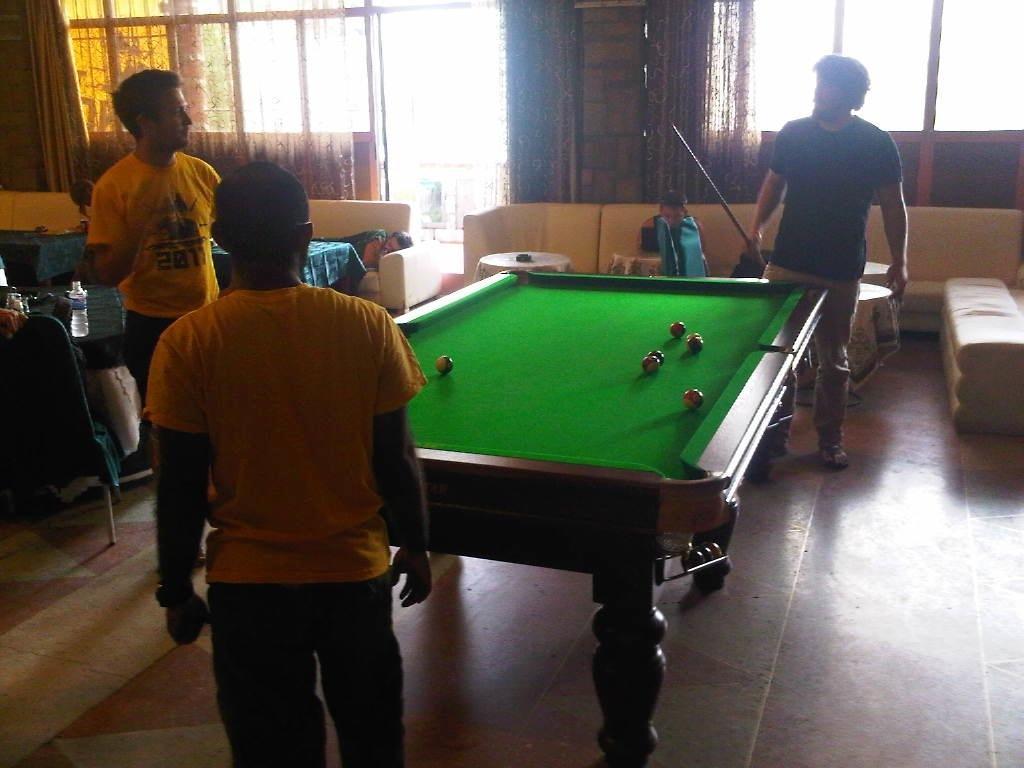Can you describe this image briefly? In this picture three of the people are playing snooker and the guys in the background are sitting in the sofa. 